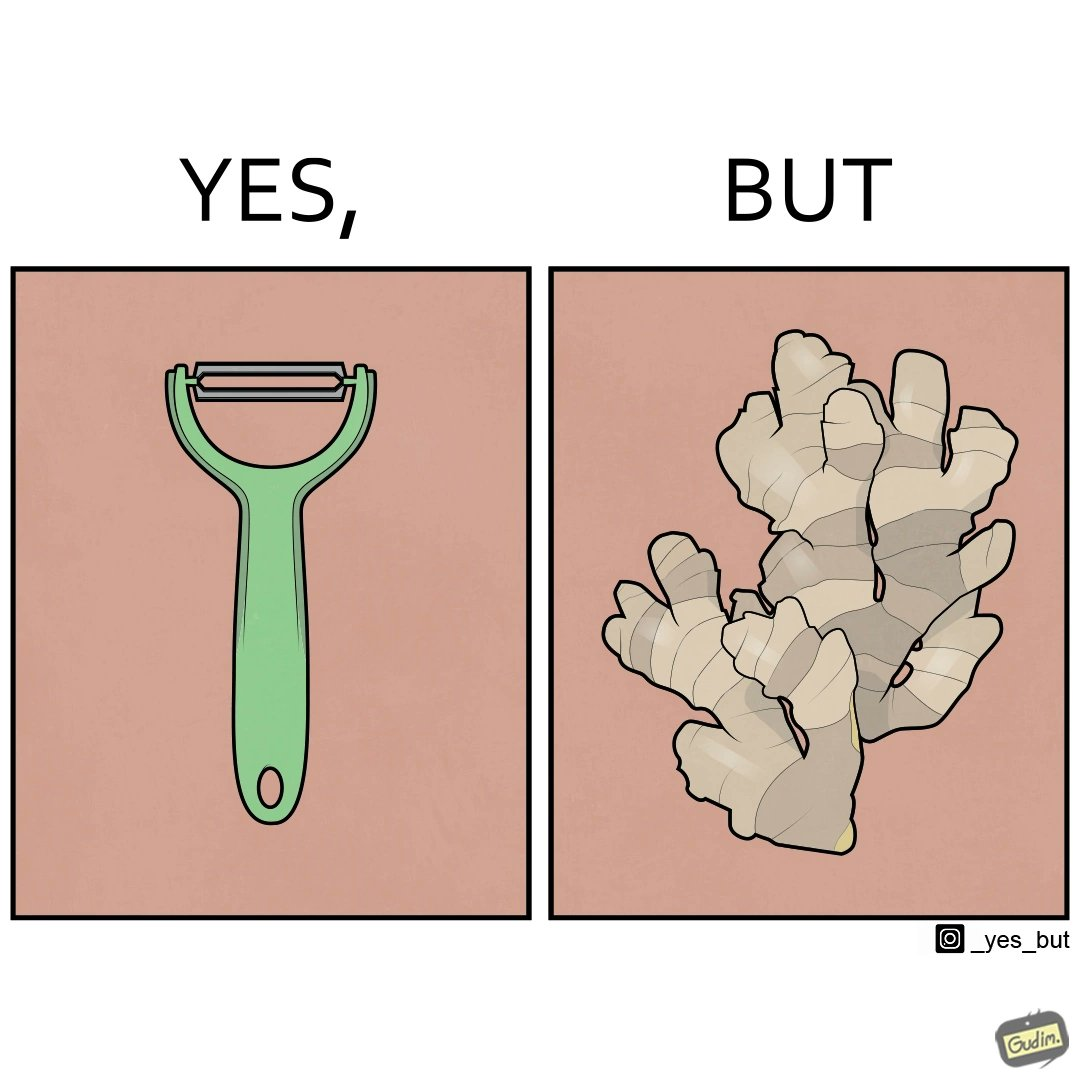Describe what you see in the left and right parts of this image. In the left part of the image: The image shows a green peeler. In the right part of the image: The image shows a ginger root with many branches and a complex shape. 